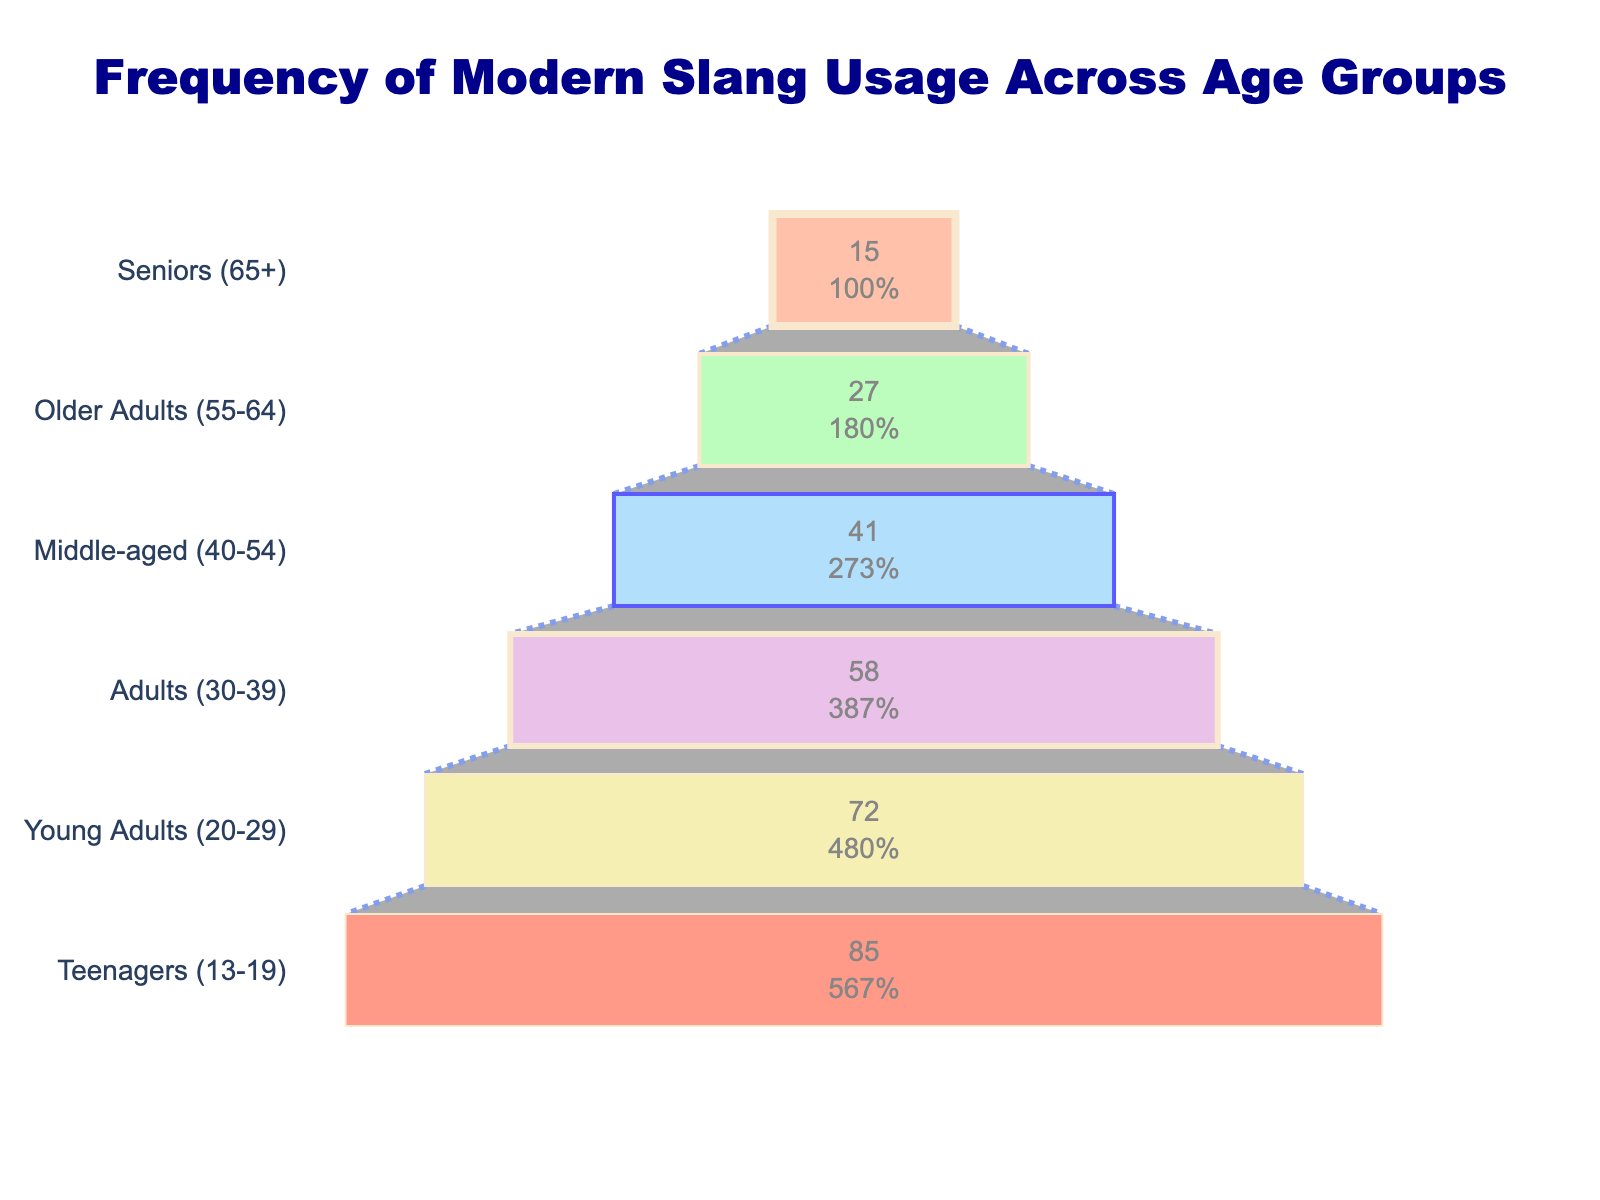What is the title of the figure? The title of the figure is located at the top and usually summarizes the main content of the plot. By reading the title, we can quickly understand what the figure is about.
Answer: Frequency of Modern Slang Usage Across Age Groups Which age group has the highest usage of modern slang terms? By examining the bars in the funnel chart, the highest bar will indicate the age group with the highest slang usage percentage. The chart shows that Teenagers (13-19) have the largest bar.
Answer: Teenagers (13-19) What is the slang term usage frequency for the Seniors (65+) age group? Each bar corresponds to an age group and displays the usage frequency in percentage. By looking at the bar labeled "Seniors (65+)", we can find the value.
Answer: 15% How does the usage frequency for Young Adults (20-29) compare to that of Older Adults (55-64)? Comparing the bars for Young Adults (20-29) and Older Adults (55-64) will show that Young Adults have a higher percentage than Older Adults. Young Adults are at 72% while Older Adults are at 27%.
Answer: Young Adults (20-29) have a higher frequency What's the difference in slang term usage frequency between Teenagers (13-19) and Adults (30-39)? By identifying the percentages for Teenagers (85%) and Adults (58%), we can calculate the difference: 85% - 58% = 27%.
Answer: 27% Which age group has the second lowest usage frequency? By examining the funnel chart, the group above the one that has the lowest frequency (Seniors at 15%) will be the second lowest. "Older Adults (55-64)" have the next smallest bar at 27%.
Answer: Older Adults (55-64) How many age groups show a slang usage frequency higher than 50%? The chart shows the following percentages for age groups: Teenagers (85%), Young Adults (72%), and Adults (58%). These are all higher than 50%. Counting these groups gives us a total of 3.
Answer: 3 What is the range of slang term usage frequency across the age groups? The range can be calculated by subtracting the lowest percentage value from the highest. Here, the lowest is Seniors (15%) and the highest is Teenagers (85%). So the range is: 85% - 15% = 70%.
Answer: 70% What percentage of Middle-aged (40-54) people use slang terms according to the chart? We can find the exact value by locating the bar labeled "Middle-aged (40-54)". The value associated with this group is 41%.
Answer: 41% 